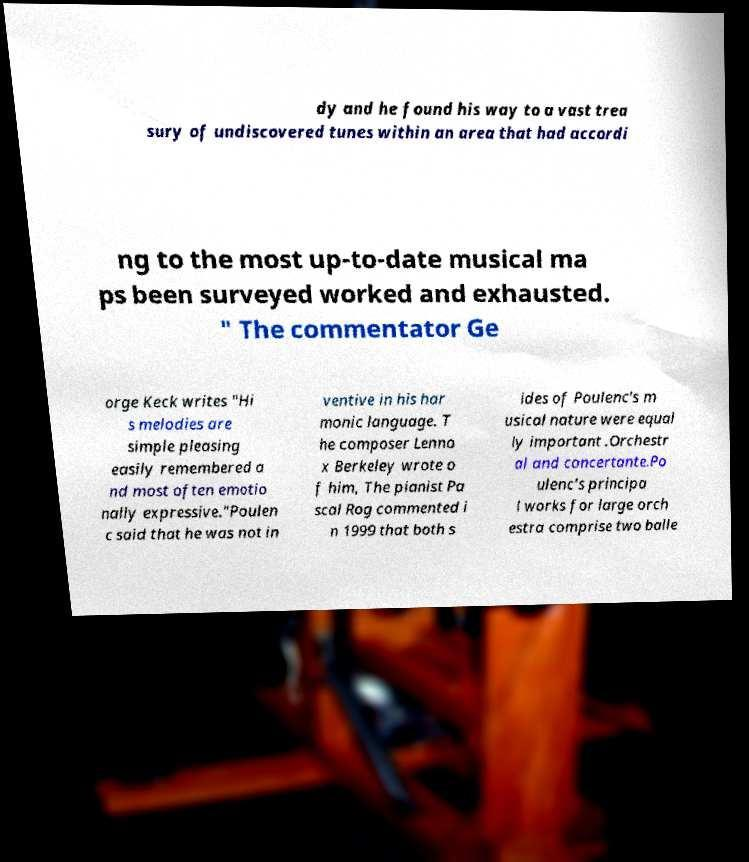Please identify and transcribe the text found in this image. dy and he found his way to a vast trea sury of undiscovered tunes within an area that had accordi ng to the most up-to-date musical ma ps been surveyed worked and exhausted. " The commentator Ge orge Keck writes "Hi s melodies are simple pleasing easily remembered a nd most often emotio nally expressive."Poulen c said that he was not in ventive in his har monic language. T he composer Lenno x Berkeley wrote o f him, The pianist Pa scal Rog commented i n 1999 that both s ides of Poulenc's m usical nature were equal ly important .Orchestr al and concertante.Po ulenc's principa l works for large orch estra comprise two balle 